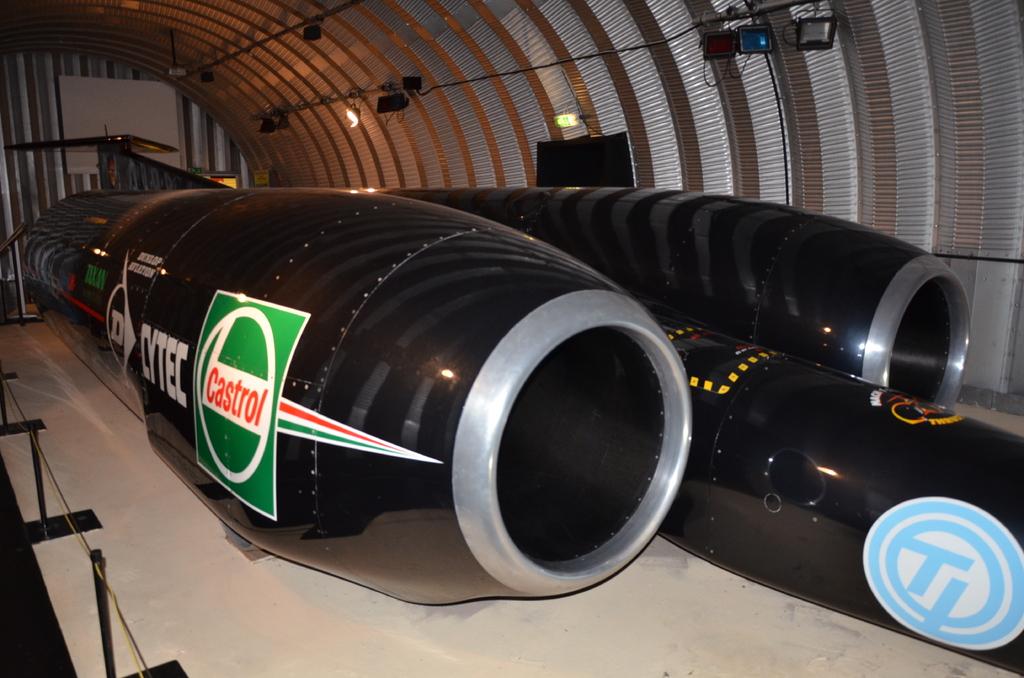What brand of oil is advertised here?
Give a very brief answer. Castrol. What does it say next to the oil brand decal?
Provide a short and direct response. Cytec. 